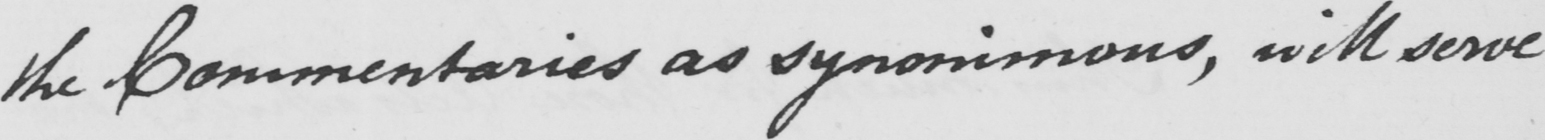What text is written in this handwritten line? the Commentaries as synonimous , will serve 